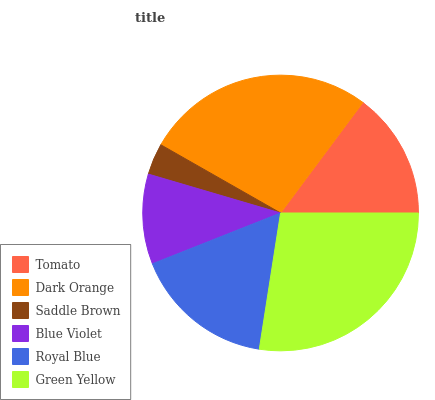Is Saddle Brown the minimum?
Answer yes or no. Yes. Is Green Yellow the maximum?
Answer yes or no. Yes. Is Dark Orange the minimum?
Answer yes or no. No. Is Dark Orange the maximum?
Answer yes or no. No. Is Dark Orange greater than Tomato?
Answer yes or no. Yes. Is Tomato less than Dark Orange?
Answer yes or no. Yes. Is Tomato greater than Dark Orange?
Answer yes or no. No. Is Dark Orange less than Tomato?
Answer yes or no. No. Is Royal Blue the high median?
Answer yes or no. Yes. Is Tomato the low median?
Answer yes or no. Yes. Is Tomato the high median?
Answer yes or no. No. Is Dark Orange the low median?
Answer yes or no. No. 